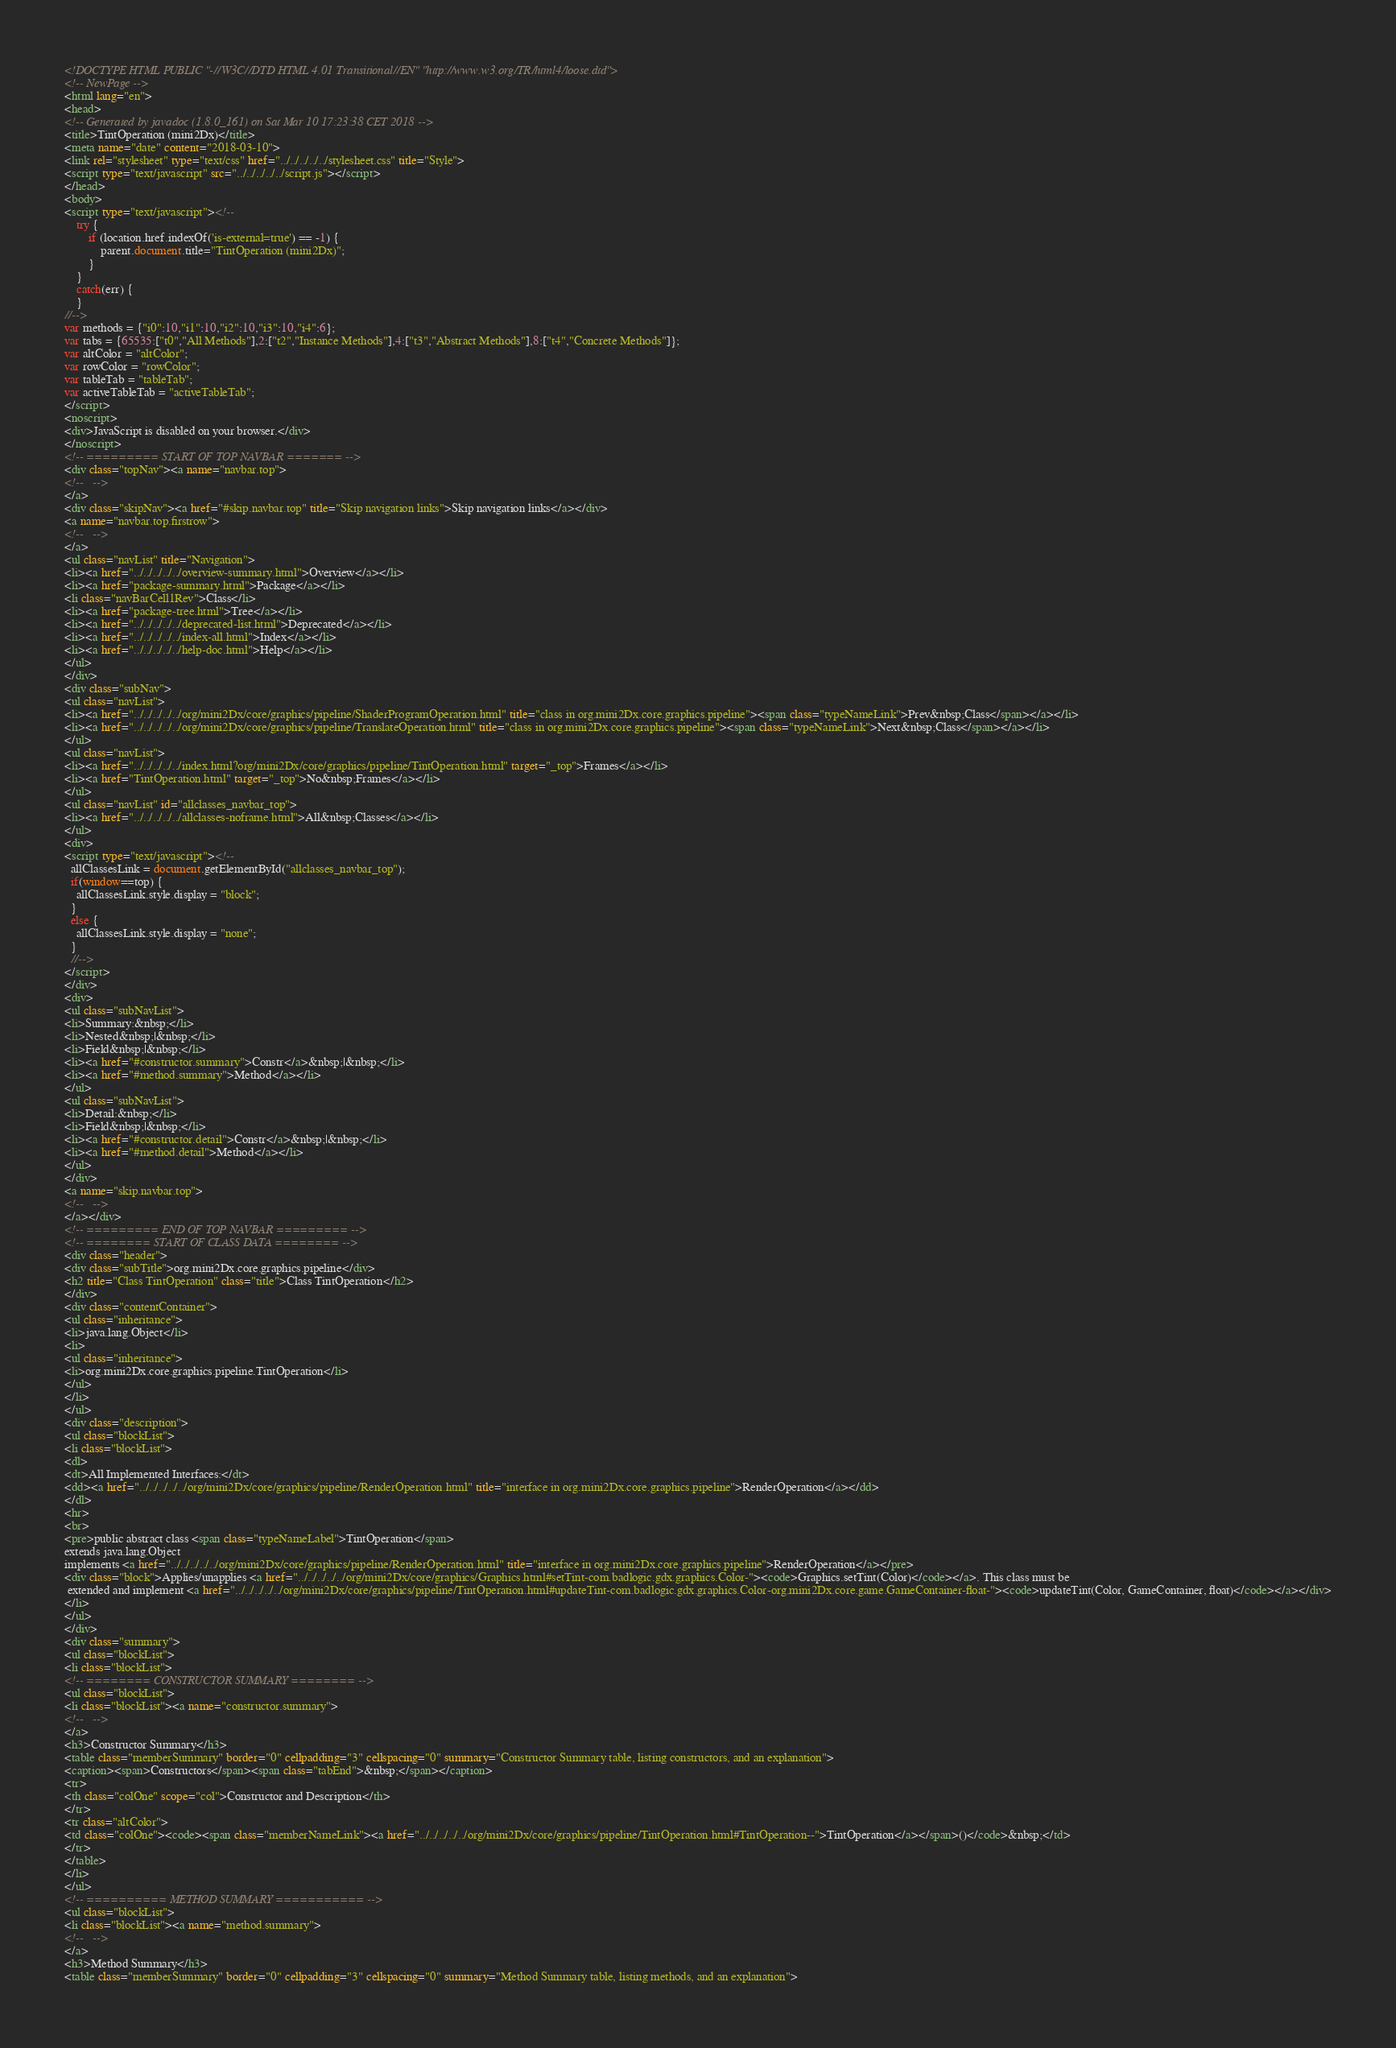Convert code to text. <code><loc_0><loc_0><loc_500><loc_500><_HTML_><!DOCTYPE HTML PUBLIC "-//W3C//DTD HTML 4.01 Transitional//EN" "http://www.w3.org/TR/html4/loose.dtd">
<!-- NewPage -->
<html lang="en">
<head>
<!-- Generated by javadoc (1.8.0_161) on Sat Mar 10 17:23:38 CET 2018 -->
<title>TintOperation (mini2Dx)</title>
<meta name="date" content="2018-03-10">
<link rel="stylesheet" type="text/css" href="../../../../../stylesheet.css" title="Style">
<script type="text/javascript" src="../../../../../script.js"></script>
</head>
<body>
<script type="text/javascript"><!--
    try {
        if (location.href.indexOf('is-external=true') == -1) {
            parent.document.title="TintOperation (mini2Dx)";
        }
    }
    catch(err) {
    }
//-->
var methods = {"i0":10,"i1":10,"i2":10,"i3":10,"i4":6};
var tabs = {65535:["t0","All Methods"],2:["t2","Instance Methods"],4:["t3","Abstract Methods"],8:["t4","Concrete Methods"]};
var altColor = "altColor";
var rowColor = "rowColor";
var tableTab = "tableTab";
var activeTableTab = "activeTableTab";
</script>
<noscript>
<div>JavaScript is disabled on your browser.</div>
</noscript>
<!-- ========= START OF TOP NAVBAR ======= -->
<div class="topNav"><a name="navbar.top">
<!--   -->
</a>
<div class="skipNav"><a href="#skip.navbar.top" title="Skip navigation links">Skip navigation links</a></div>
<a name="navbar.top.firstrow">
<!--   -->
</a>
<ul class="navList" title="Navigation">
<li><a href="../../../../../overview-summary.html">Overview</a></li>
<li><a href="package-summary.html">Package</a></li>
<li class="navBarCell1Rev">Class</li>
<li><a href="package-tree.html">Tree</a></li>
<li><a href="../../../../../deprecated-list.html">Deprecated</a></li>
<li><a href="../../../../../index-all.html">Index</a></li>
<li><a href="../../../../../help-doc.html">Help</a></li>
</ul>
</div>
<div class="subNav">
<ul class="navList">
<li><a href="../../../../../org/mini2Dx/core/graphics/pipeline/ShaderProgramOperation.html" title="class in org.mini2Dx.core.graphics.pipeline"><span class="typeNameLink">Prev&nbsp;Class</span></a></li>
<li><a href="../../../../../org/mini2Dx/core/graphics/pipeline/TranslateOperation.html" title="class in org.mini2Dx.core.graphics.pipeline"><span class="typeNameLink">Next&nbsp;Class</span></a></li>
</ul>
<ul class="navList">
<li><a href="../../../../../index.html?org/mini2Dx/core/graphics/pipeline/TintOperation.html" target="_top">Frames</a></li>
<li><a href="TintOperation.html" target="_top">No&nbsp;Frames</a></li>
</ul>
<ul class="navList" id="allclasses_navbar_top">
<li><a href="../../../../../allclasses-noframe.html">All&nbsp;Classes</a></li>
</ul>
<div>
<script type="text/javascript"><!--
  allClassesLink = document.getElementById("allclasses_navbar_top");
  if(window==top) {
    allClassesLink.style.display = "block";
  }
  else {
    allClassesLink.style.display = "none";
  }
  //-->
</script>
</div>
<div>
<ul class="subNavList">
<li>Summary:&nbsp;</li>
<li>Nested&nbsp;|&nbsp;</li>
<li>Field&nbsp;|&nbsp;</li>
<li><a href="#constructor.summary">Constr</a>&nbsp;|&nbsp;</li>
<li><a href="#method.summary">Method</a></li>
</ul>
<ul class="subNavList">
<li>Detail:&nbsp;</li>
<li>Field&nbsp;|&nbsp;</li>
<li><a href="#constructor.detail">Constr</a>&nbsp;|&nbsp;</li>
<li><a href="#method.detail">Method</a></li>
</ul>
</div>
<a name="skip.navbar.top">
<!--   -->
</a></div>
<!-- ========= END OF TOP NAVBAR ========= -->
<!-- ======== START OF CLASS DATA ======== -->
<div class="header">
<div class="subTitle">org.mini2Dx.core.graphics.pipeline</div>
<h2 title="Class TintOperation" class="title">Class TintOperation</h2>
</div>
<div class="contentContainer">
<ul class="inheritance">
<li>java.lang.Object</li>
<li>
<ul class="inheritance">
<li>org.mini2Dx.core.graphics.pipeline.TintOperation</li>
</ul>
</li>
</ul>
<div class="description">
<ul class="blockList">
<li class="blockList">
<dl>
<dt>All Implemented Interfaces:</dt>
<dd><a href="../../../../../org/mini2Dx/core/graphics/pipeline/RenderOperation.html" title="interface in org.mini2Dx.core.graphics.pipeline">RenderOperation</a></dd>
</dl>
<hr>
<br>
<pre>public abstract class <span class="typeNameLabel">TintOperation</span>
extends java.lang.Object
implements <a href="../../../../../org/mini2Dx/core/graphics/pipeline/RenderOperation.html" title="interface in org.mini2Dx.core.graphics.pipeline">RenderOperation</a></pre>
<div class="block">Applies/unapplies <a href="../../../../../org/mini2Dx/core/graphics/Graphics.html#setTint-com.badlogic.gdx.graphics.Color-"><code>Graphics.setTint(Color)</code></a>. This class must be
 extended and implement <a href="../../../../../org/mini2Dx/core/graphics/pipeline/TintOperation.html#updateTint-com.badlogic.gdx.graphics.Color-org.mini2Dx.core.game.GameContainer-float-"><code>updateTint(Color, GameContainer, float)</code></a></div>
</li>
</ul>
</div>
<div class="summary">
<ul class="blockList">
<li class="blockList">
<!-- ======== CONSTRUCTOR SUMMARY ======== -->
<ul class="blockList">
<li class="blockList"><a name="constructor.summary">
<!--   -->
</a>
<h3>Constructor Summary</h3>
<table class="memberSummary" border="0" cellpadding="3" cellspacing="0" summary="Constructor Summary table, listing constructors, and an explanation">
<caption><span>Constructors</span><span class="tabEnd">&nbsp;</span></caption>
<tr>
<th class="colOne" scope="col">Constructor and Description</th>
</tr>
<tr class="altColor">
<td class="colOne"><code><span class="memberNameLink"><a href="../../../../../org/mini2Dx/core/graphics/pipeline/TintOperation.html#TintOperation--">TintOperation</a></span>()</code>&nbsp;</td>
</tr>
</table>
</li>
</ul>
<!-- ========== METHOD SUMMARY =========== -->
<ul class="blockList">
<li class="blockList"><a name="method.summary">
<!--   -->
</a>
<h3>Method Summary</h3>
<table class="memberSummary" border="0" cellpadding="3" cellspacing="0" summary="Method Summary table, listing methods, and an explanation"></code> 